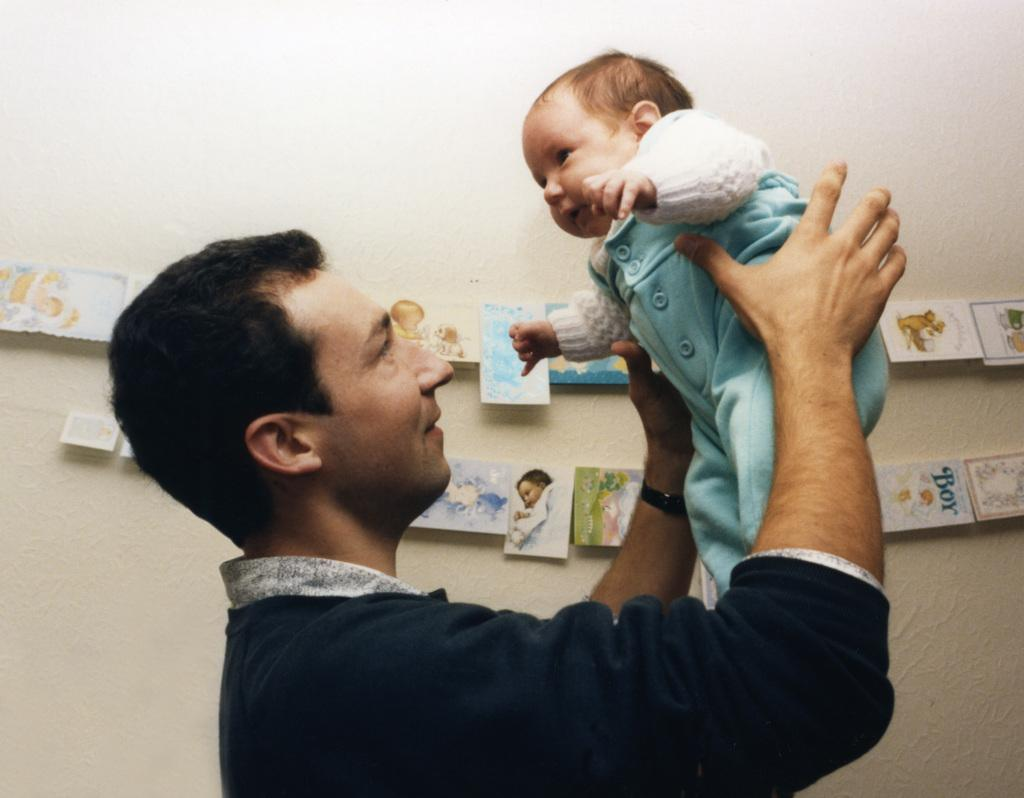What is happening in the center of the image? There is a person holding a baby in the center of the image. What can be seen in the background of the image? There is a wall in the background of the image. What is on the wall in the background? There are photos on the wall in the background. What type of learning is the dog engaged in while sitting next to the person holding the baby? There is no dog present in the image, so it is not possible to answer that question. 